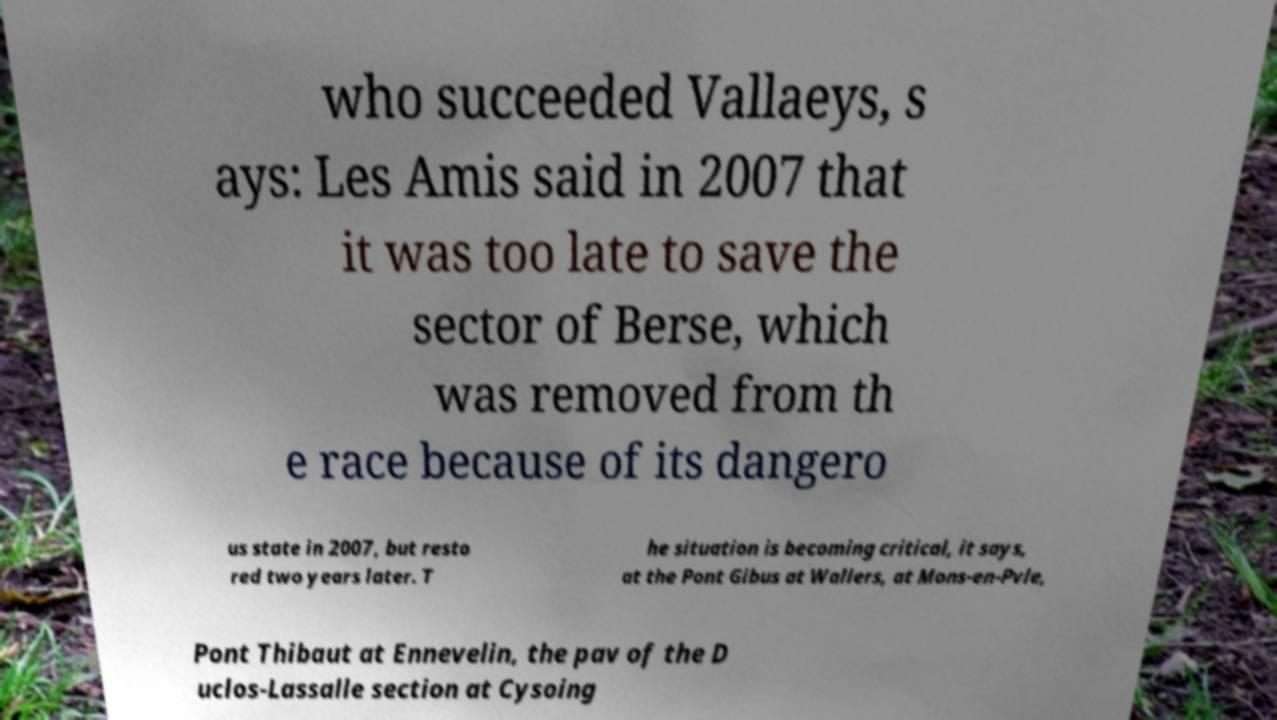Please read and relay the text visible in this image. What does it say? who succeeded Vallaeys, s ays: Les Amis said in 2007 that it was too late to save the sector of Berse, which was removed from th e race because of its dangero us state in 2007, but resto red two years later. T he situation is becoming critical, it says, at the Pont Gibus at Wallers, at Mons-en-Pvle, Pont Thibaut at Ennevelin, the pav of the D uclos-Lassalle section at Cysoing 